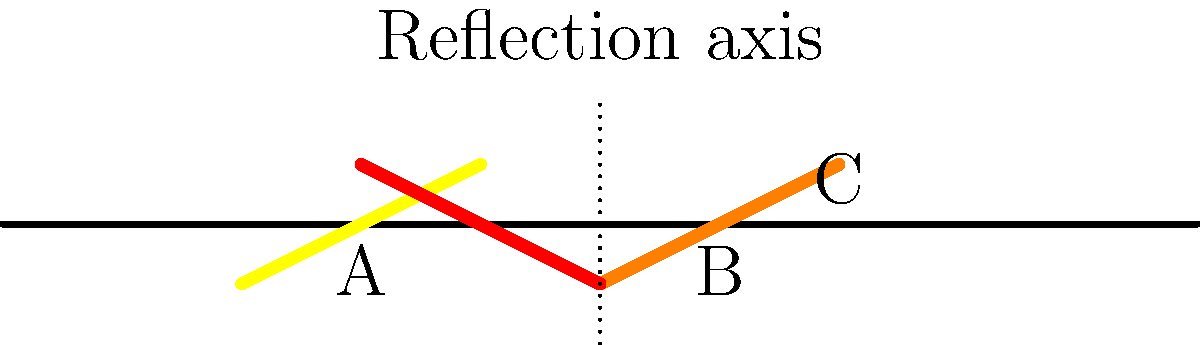A railway platform edge warning strip is initially positioned at point A. It is then translated 3 units to the right to point B, and finally reflected across the vertical line passing through (5,0). What transformation would directly move the warning strip from its initial position at A to its final position at C? To solve this problem, let's break it down into steps:

1. The initial strip is at point A.
2. It is translated 3 units to the right to point B. This can be represented as $T_{(3,0)}$.
3. It is then reflected across the line x = 5. This reflection can be represented as $R_{x=5}$.

The composite transformation from A to C is therefore $R_{x=5} \circ T_{(3,0)}$.

To find a single transformation that would move the strip directly from A to C:

4. Observe that the final position C is to the right of the reflection axis.
5. The distance from A to the reflection axis is 3 units, and C is 2 units to the right of the axis.
6. This means the total horizontal displacement is 5 units to the right.
7. The strip is also flipped vertically in its final position.

Therefore, the single transformation that would move the strip from A to C is a glide reflection:
- A translation of 5 units to the right, followed by
- A reflection over the vertical line x = 5

This can be written as $R_{x=5} \circ T_{(5,0)}$ or described as a glide reflection with the vertical line x = 5 as the axis and a glide factor of 5 units to the right.
Answer: Glide reflection: $R_{x=5} \circ T_{(5,0)}$ 